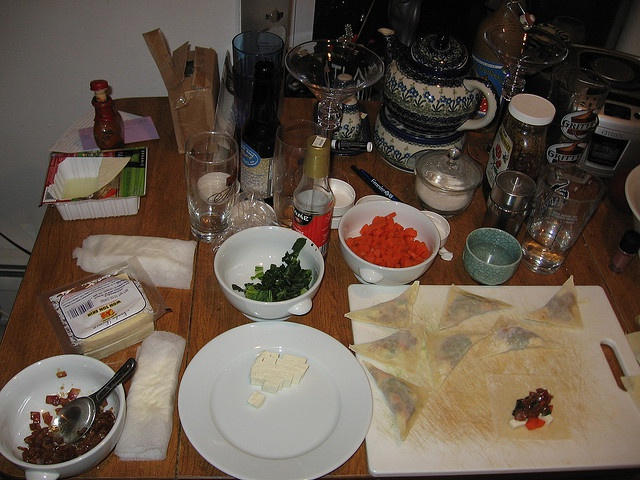Describe the objects in this image and their specific colors. I can see dining table in black, maroon, and gray tones, bowl in black, darkgray, gray, and maroon tones, dining table in black, maroon, and gray tones, bowl in black, darkgray, gray, and darkgreen tones, and bowl in black, maroon, darkgray, and gray tones in this image. 